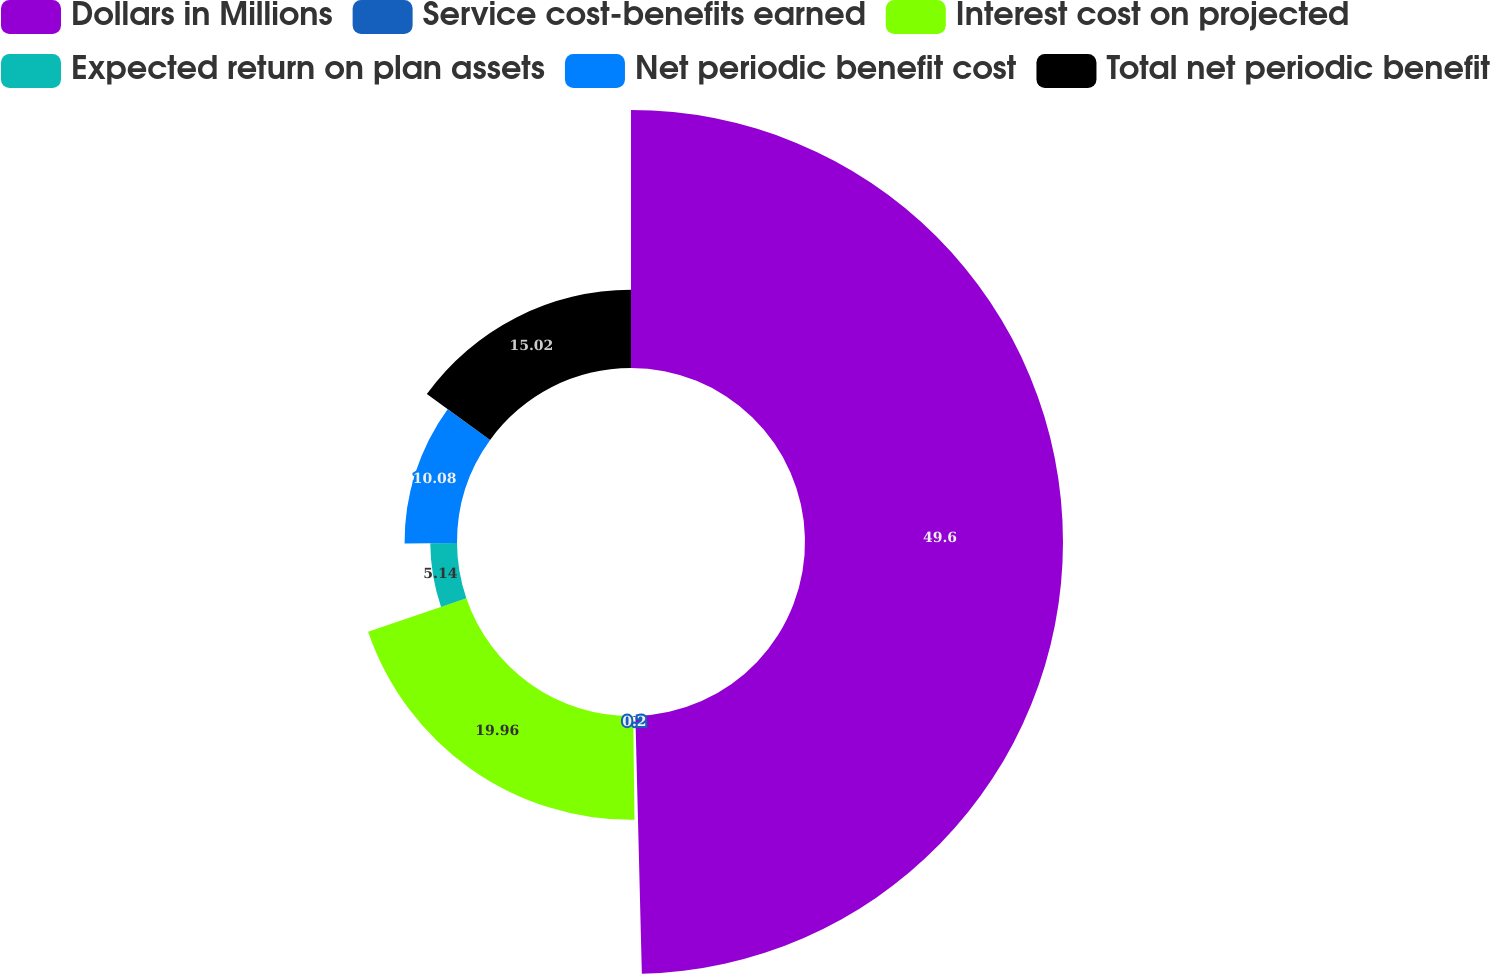Convert chart. <chart><loc_0><loc_0><loc_500><loc_500><pie_chart><fcel>Dollars in Millions<fcel>Service cost-benefits earned<fcel>Interest cost on projected<fcel>Expected return on plan assets<fcel>Net periodic benefit cost<fcel>Total net periodic benefit<nl><fcel>49.6%<fcel>0.2%<fcel>19.96%<fcel>5.14%<fcel>10.08%<fcel>15.02%<nl></chart> 